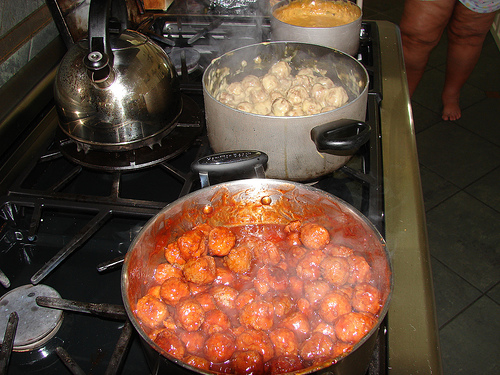<image>
Is the white food behind the pot? No. The white food is not behind the pot. From this viewpoint, the white food appears to be positioned elsewhere in the scene. 